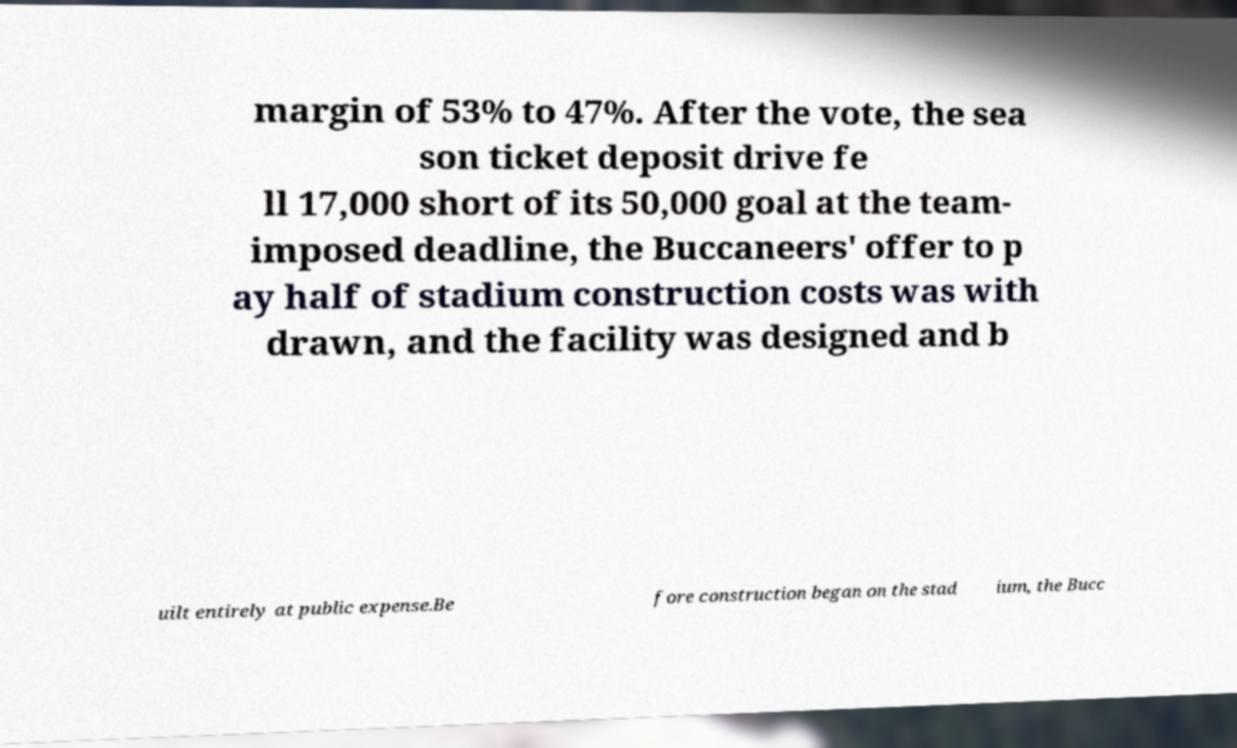Can you read and provide the text displayed in the image?This photo seems to have some interesting text. Can you extract and type it out for me? margin of 53% to 47%. After the vote, the sea son ticket deposit drive fe ll 17,000 short of its 50,000 goal at the team- imposed deadline, the Buccaneers' offer to p ay half of stadium construction costs was with drawn, and the facility was designed and b uilt entirely at public expense.Be fore construction began on the stad ium, the Bucc 